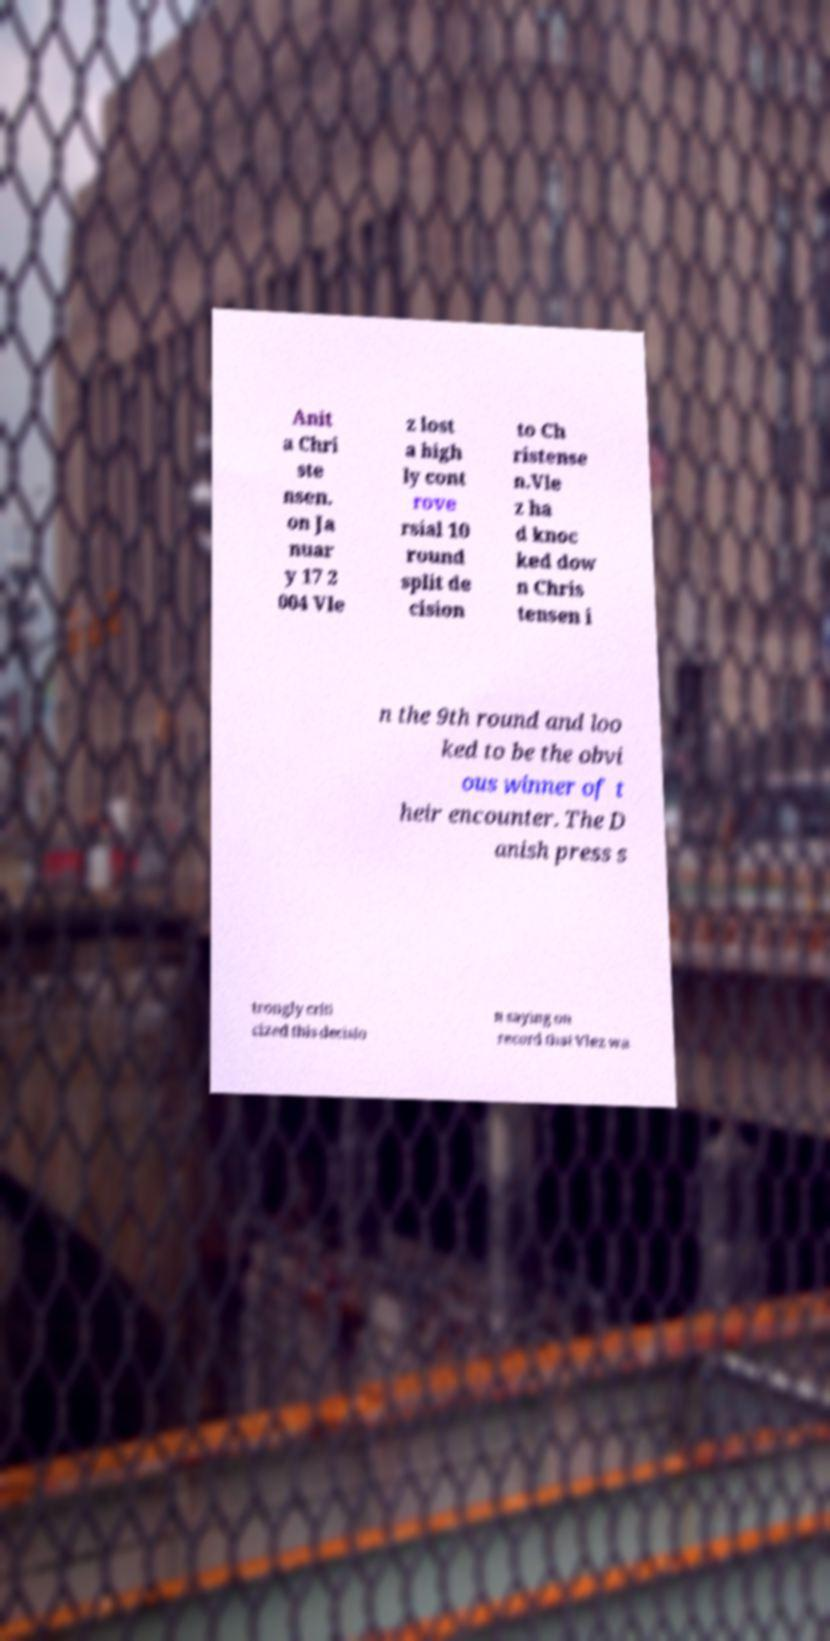What messages or text are displayed in this image? I need them in a readable, typed format. Anit a Chri ste nsen. on Ja nuar y 17 2 004 Vle z lost a high ly cont rove rsial 10 round split de cision to Ch ristense n.Vle z ha d knoc ked dow n Chris tensen i n the 9th round and loo ked to be the obvi ous winner of t heir encounter. The D anish press s trongly criti cized this decisio n saying on record that Vlez wa 